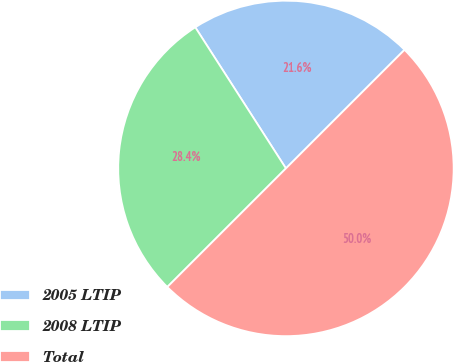Convert chart. <chart><loc_0><loc_0><loc_500><loc_500><pie_chart><fcel>2005 LTIP<fcel>2008 LTIP<fcel>Total<nl><fcel>21.59%<fcel>28.41%<fcel>50.0%<nl></chart> 